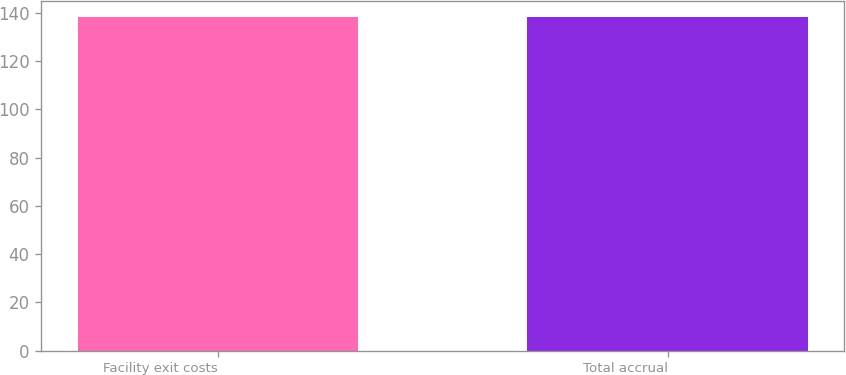Convert chart. <chart><loc_0><loc_0><loc_500><loc_500><bar_chart><fcel>Facility exit costs<fcel>Total accrual<nl><fcel>138<fcel>138.1<nl></chart> 